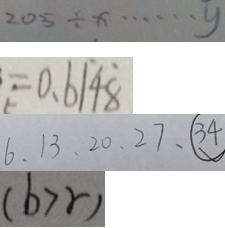Convert formula to latex. <formula><loc_0><loc_0><loc_500><loc_500>2 0 5 \div x \cdots y 
 = 0 . 6 \dot { 1 } 4 \dot { 8 } 
 6 , 1 3 , 2 0 , 2 7 , \textcircled { 3 4 } 
 ( b > r )</formula> 